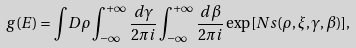Convert formula to latex. <formula><loc_0><loc_0><loc_500><loc_500>g ( E ) = { \int } D \rho \int ^ { + \infty } _ { - \infty } \frac { d \gamma } { 2 { \pi } i } \int ^ { + { \infty } } _ { - { \infty } } \frac { d \beta } { 2 { \pi } i } \exp [ N s ( \rho , \xi , \gamma , \beta ) ] ,</formula> 